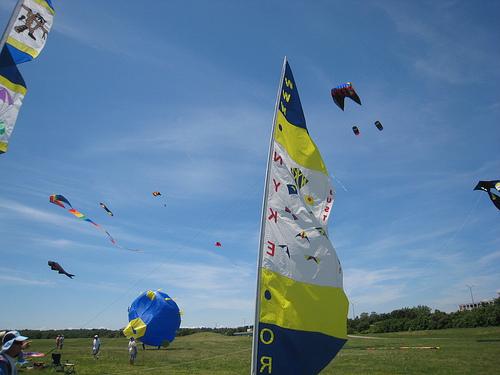What color is the ground?
Give a very brief answer. Green. How many kites are in the sky?
Short answer required. 8. Was this photo taken during the day?
Give a very brief answer. Yes. 